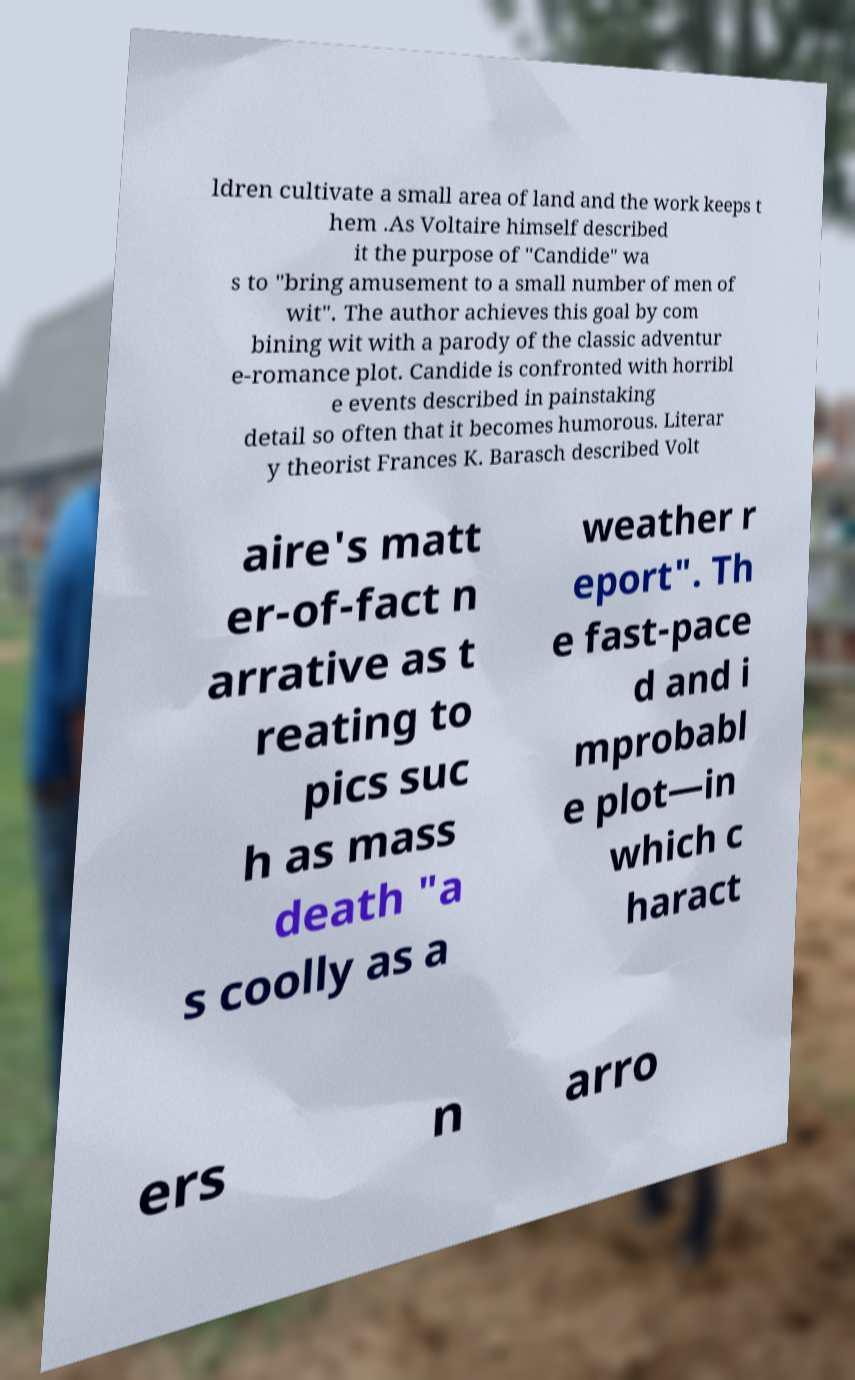Could you extract and type out the text from this image? ldren cultivate a small area of land and the work keeps t hem .As Voltaire himself described it the purpose of "Candide" wa s to "bring amusement to a small number of men of wit". The author achieves this goal by com bining wit with a parody of the classic adventur e-romance plot. Candide is confronted with horribl e events described in painstaking detail so often that it becomes humorous. Literar y theorist Frances K. Barasch described Volt aire's matt er-of-fact n arrative as t reating to pics suc h as mass death "a s coolly as a weather r eport". Th e fast-pace d and i mprobabl e plot—in which c haract ers n arro 